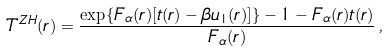<formula> <loc_0><loc_0><loc_500><loc_500>T ^ { Z H } ( r ) = \frac { \exp \{ F _ { \alpha } ( r ) [ t ( r ) - \beta u _ { 1 } ( r ) ] \} - 1 - F _ { \alpha } ( r ) t ( r ) } { F _ { \alpha } ( r ) } \, ,</formula> 